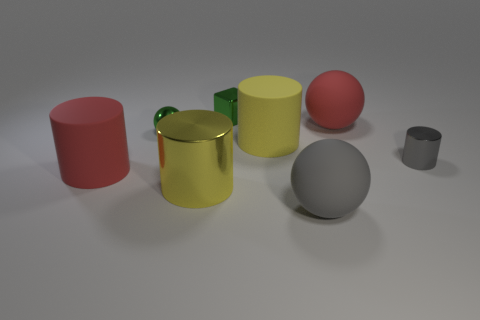Is the material of the red object in front of the tiny metal cylinder the same as the sphere that is in front of the red cylinder? Based on the visual characteristics observed in the image, both the red object and the sphere appear to have a similar matte finish and reflect light in a consistent manner, suggesting they might be made from materials with comparable properties. However, without more specific information, it cannot be definitively determined if they are composed of the exact same material. 